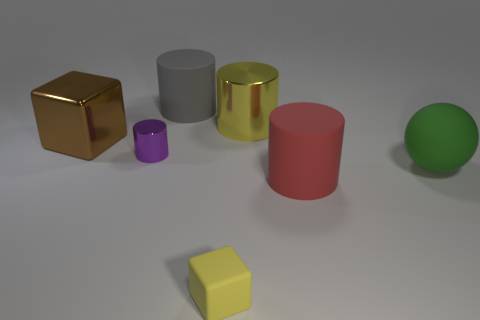Subtract all red rubber cylinders. How many cylinders are left? 3 Subtract all purple cylinders. How many cylinders are left? 3 Add 3 big matte cylinders. How many objects exist? 10 Subtract all blue cylinders. Subtract all purple balls. How many cylinders are left? 4 Subtract all blocks. How many objects are left? 5 Add 5 large green balls. How many large green balls are left? 6 Add 4 big gray rubber things. How many big gray rubber things exist? 5 Subtract 1 purple cylinders. How many objects are left? 6 Subtract all blue metal things. Subtract all big spheres. How many objects are left? 6 